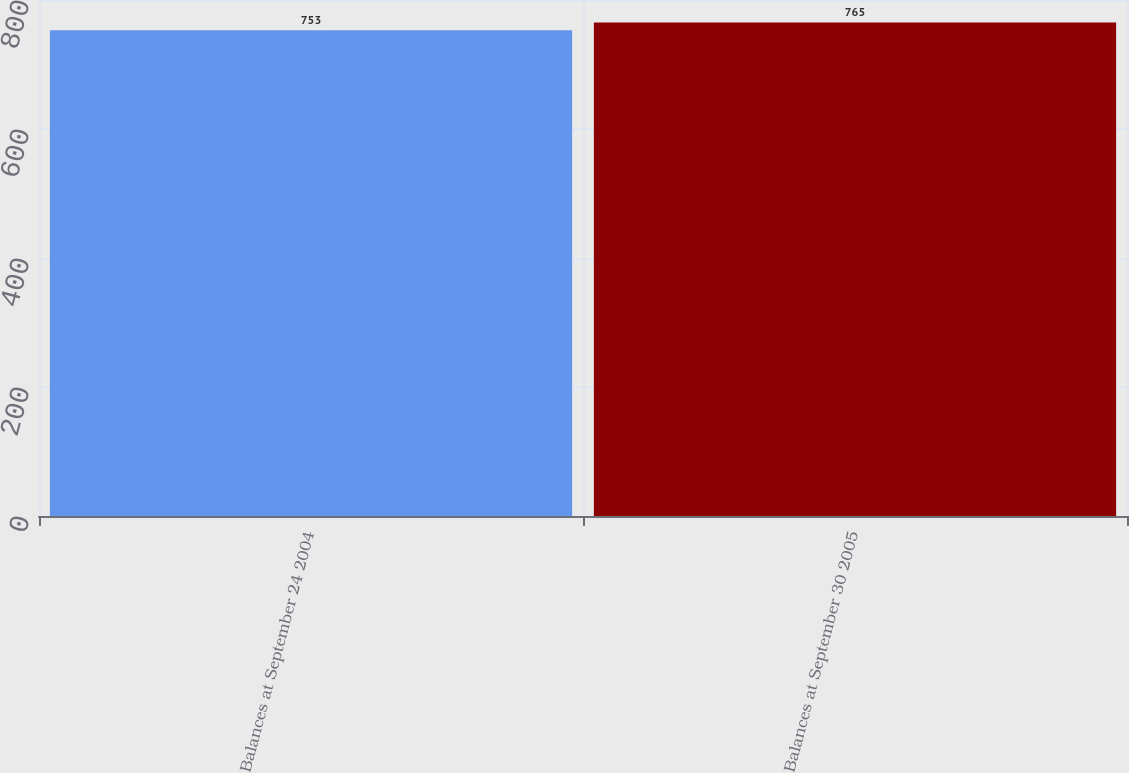Convert chart to OTSL. <chart><loc_0><loc_0><loc_500><loc_500><bar_chart><fcel>Balances at September 24 2004<fcel>Balances at September 30 2005<nl><fcel>753<fcel>765<nl></chart> 